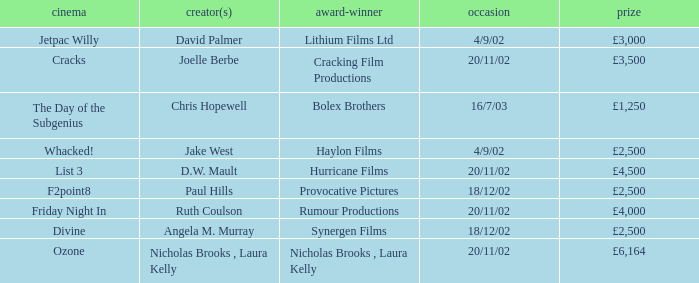Who won an award of £3,000 on 4/9/02? Lithium Films Ltd. 